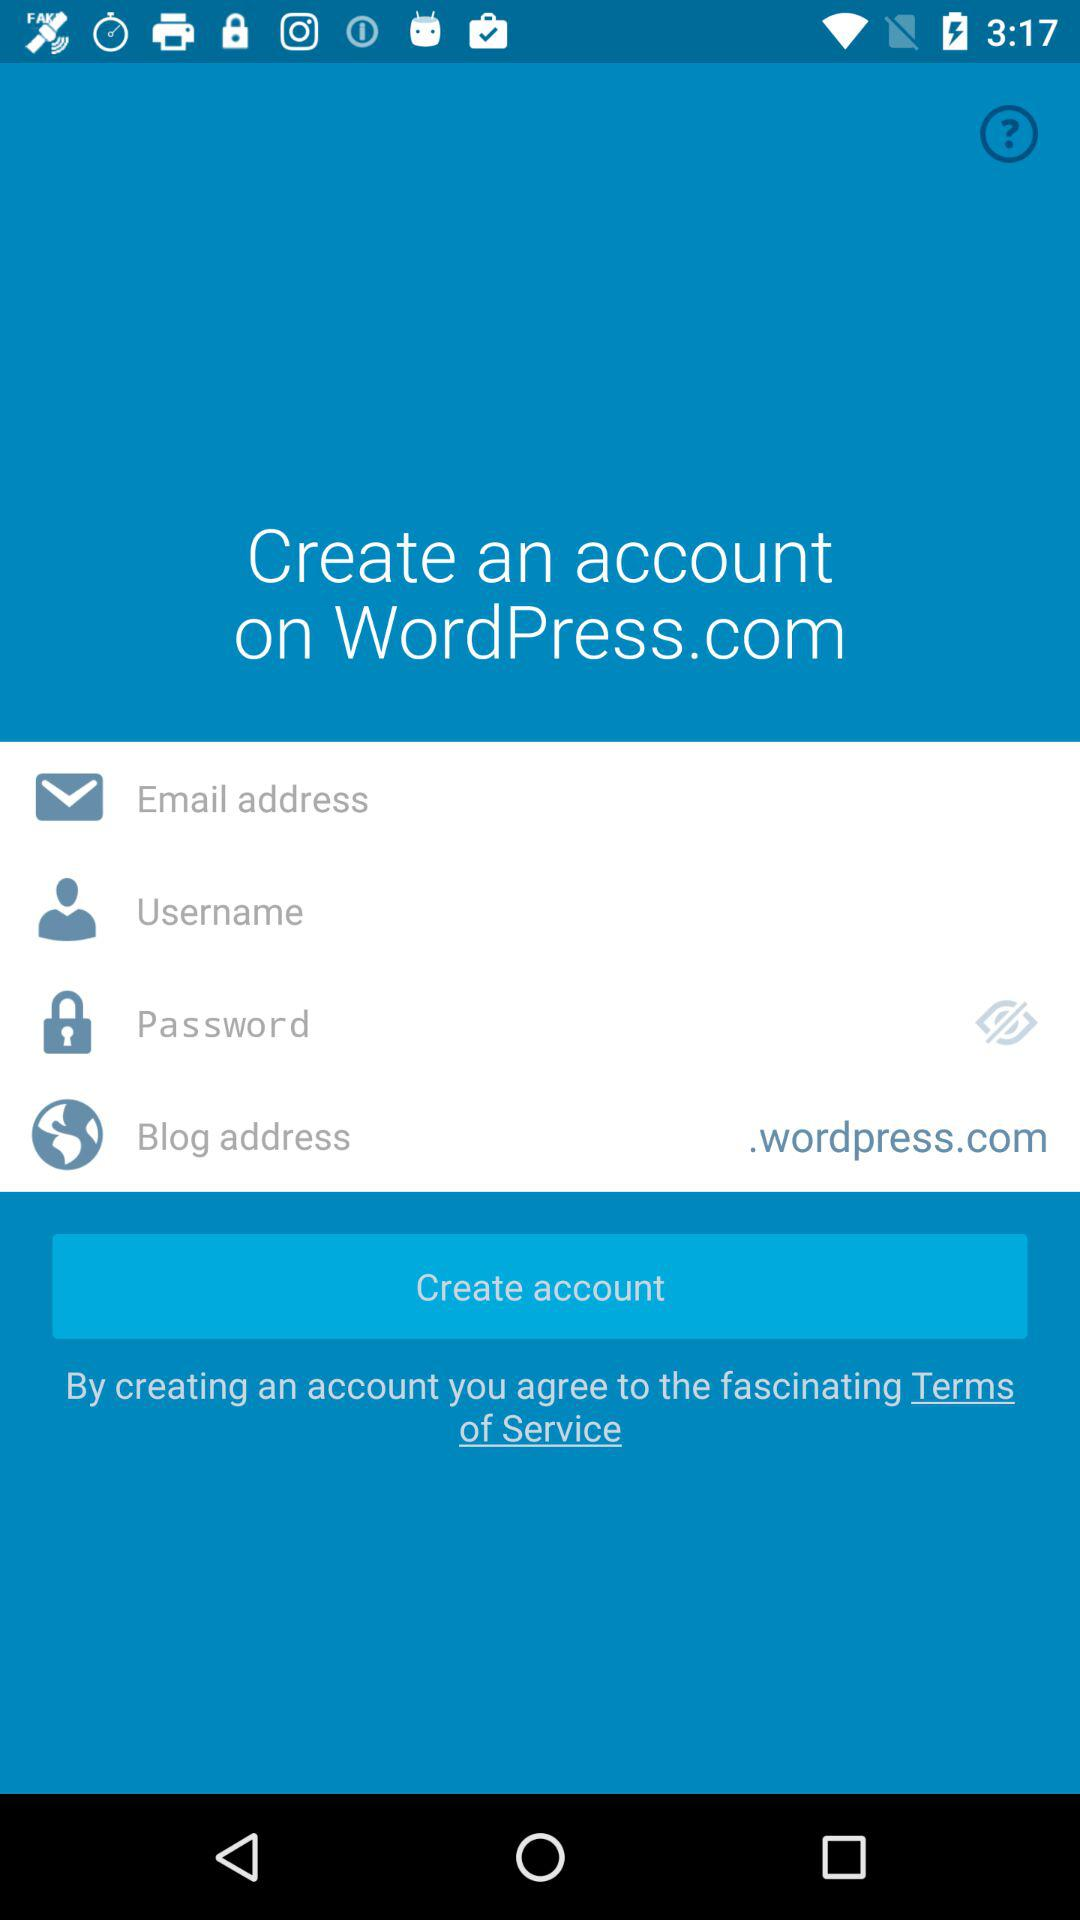What is the given blog address?
When the provided information is insufficient, respond with <no answer>. <no answer> 